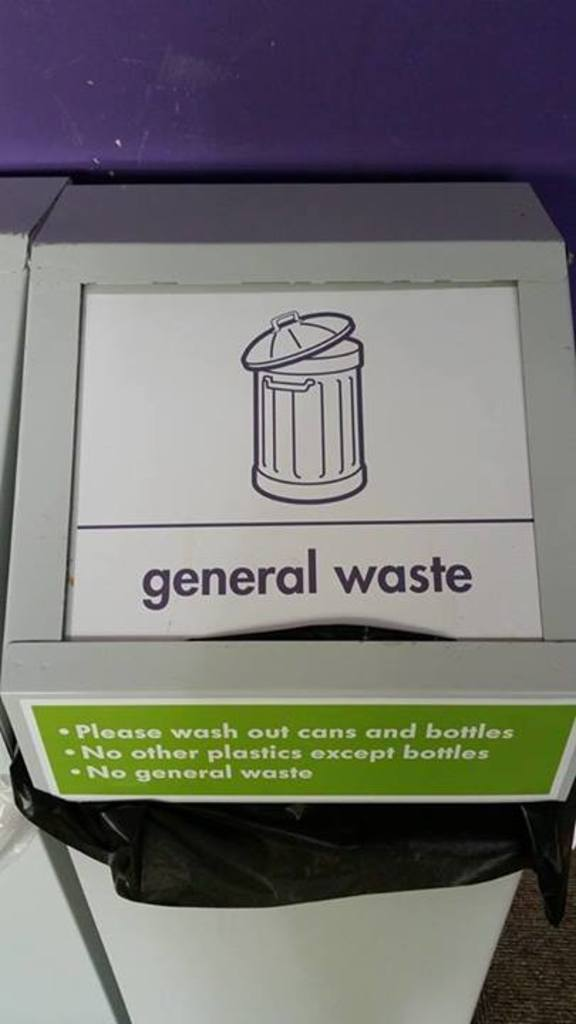What is this photo about? The photo shows a white waste bin with a modified label that clarifies its intended use. The label, in a contrasting green and white color scheme, indicates 'general waste' but with specific restrictions. It directs users to only dispose of washed out cans and bottles, explicitly prohibits other types of plastic except for bottles and instructs not to use the bin for general waste. This indicates a targeted approach towards recycling and managing waste more effectively by avoiding contamination common in recycling processes. 